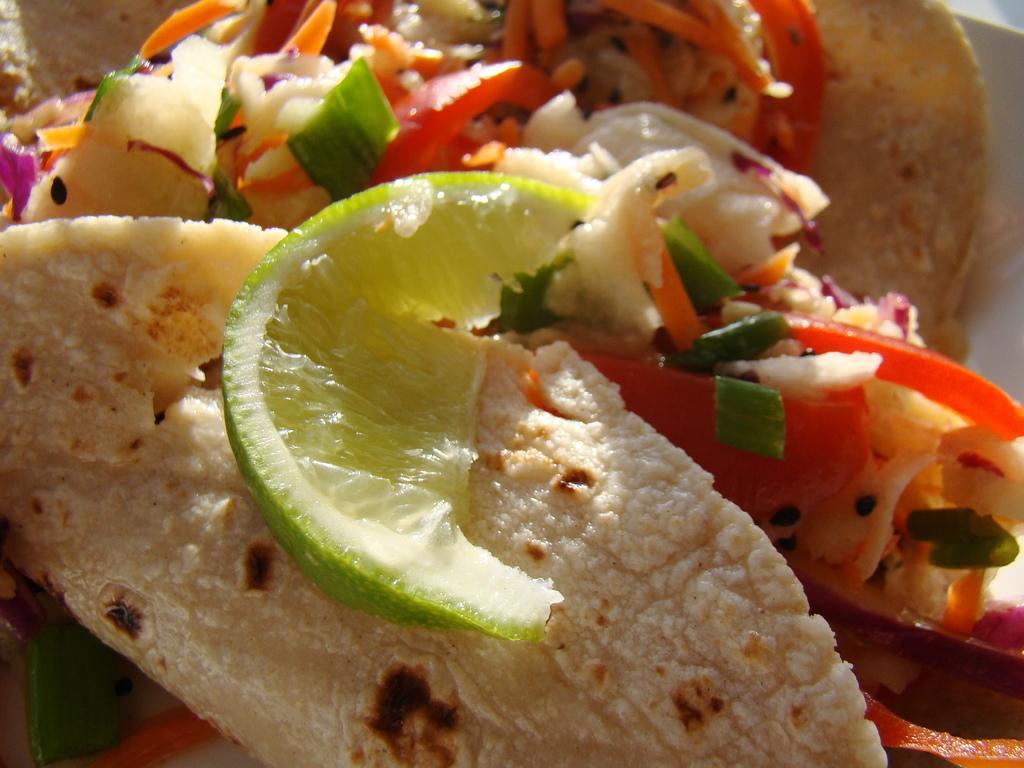Please provide a concise description of this image. In this picture we can see a piece of sweet lemon, a tortilla and some other food present here. 